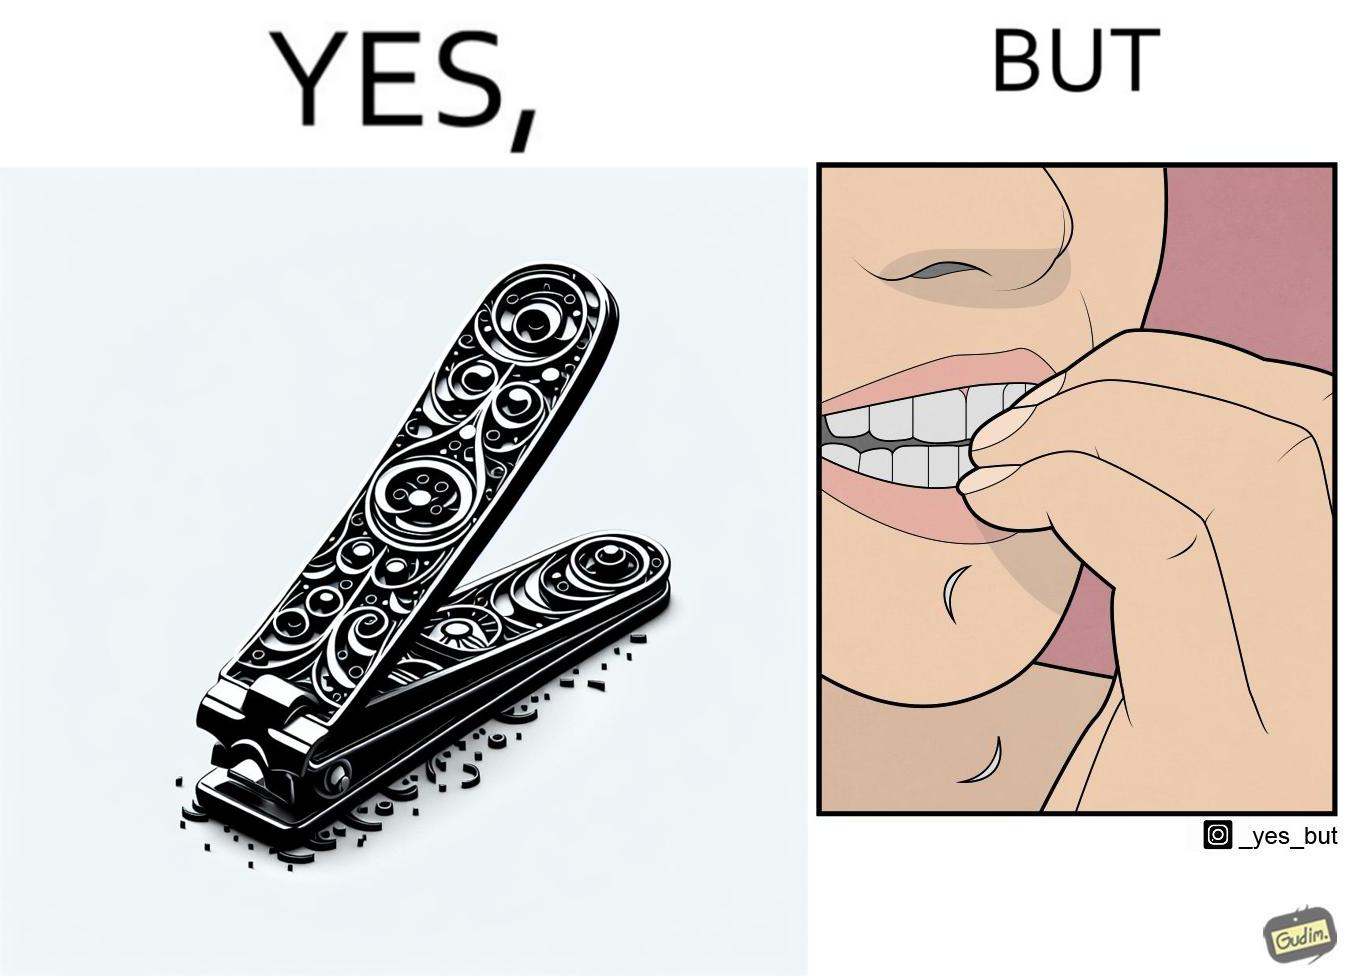Describe what you see in the left and right parts of this image. In the left part of the image: a nail clipper In the right part of the image: a person biting their nails to cut them 